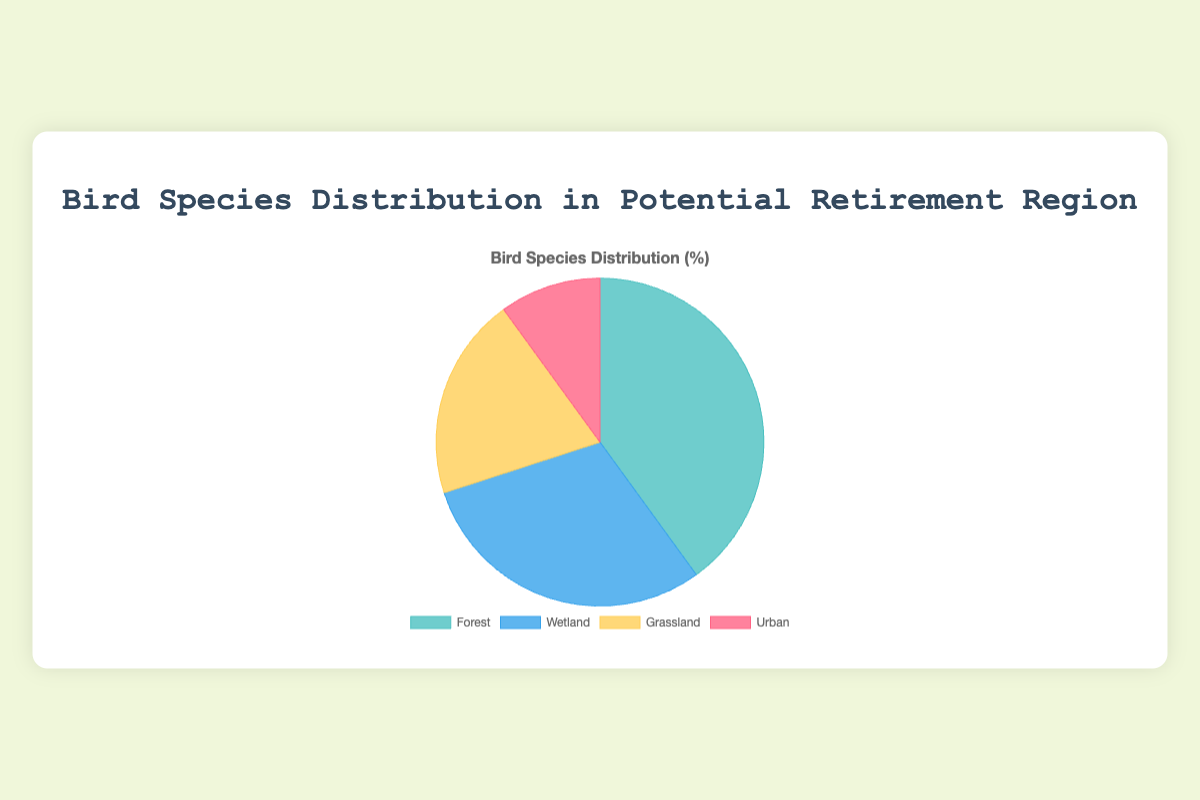What percentage of bird species are found in forest and wetland habitats combined? To find the percentage of bird species in forest and wetland habitats combined, sum the percentages of each: Forest (40%) and Wetland (30%). So, 40 + 30 = 70%.
Answer: 70% Which habitat has the smallest distribution of bird species? Examine the percentages for each habitat: Forest (40%), Wetland (30%), Grassland (20%), Urban (10%). The Urban habitat has the smallest percentage.
Answer: Urban Is the percentage of bird species in grassland habitat more than double that in urban habitat? Compare the percentages: Grassland (20%) and Urban (10%). Since 20% is exactly twice 10%, it is not more than double.
Answer: No What is the difference in percentage between forest and grassland habitats? Subtract the percentage of bird species in Grassland (20%) from that in Forest (40%): 40 - 20 = 20%.
Answer: 20% Which habitat has the second highest distribution of bird species? Examine the percentages to rank them: Forest (40%), Wetland (30%), Grassland (20%), Urban (10%). The Wetland habitat has the second highest percentage at 30%.
Answer: Wetland What is the average percentage of bird species across all habitats? To find the average, sum the percentages and divide by the number of habitats: (40 + 30 + 20 + 10) / 4 = 100 / 4 = 25%.
Answer: 25% If the percentage distribution in the urban habitat doubled, what would be its new percentage? Currently, the Urban habitat has 10%. If this percentage doubled, it would be 10 * 2 = 20%.
Answer: 20% Which habitat is represented by the color blue in the pie chart? According to the visual attributes provided, the color blue represents the Wetland habitat.
Answer: Wetland 